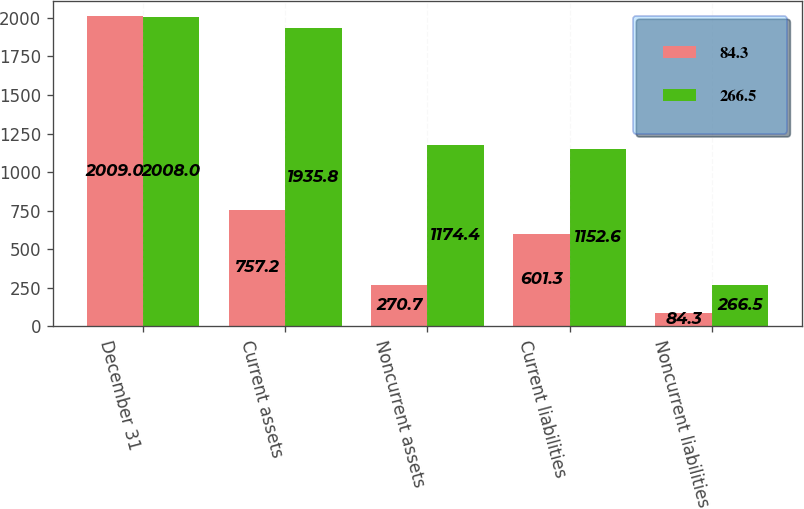Convert chart to OTSL. <chart><loc_0><loc_0><loc_500><loc_500><stacked_bar_chart><ecel><fcel>December 31<fcel>Current assets<fcel>Noncurrent assets<fcel>Current liabilities<fcel>Noncurrent liabilities<nl><fcel>84.3<fcel>2009<fcel>757.2<fcel>270.7<fcel>601.3<fcel>84.3<nl><fcel>266.5<fcel>2008<fcel>1935.8<fcel>1174.4<fcel>1152.6<fcel>266.5<nl></chart> 